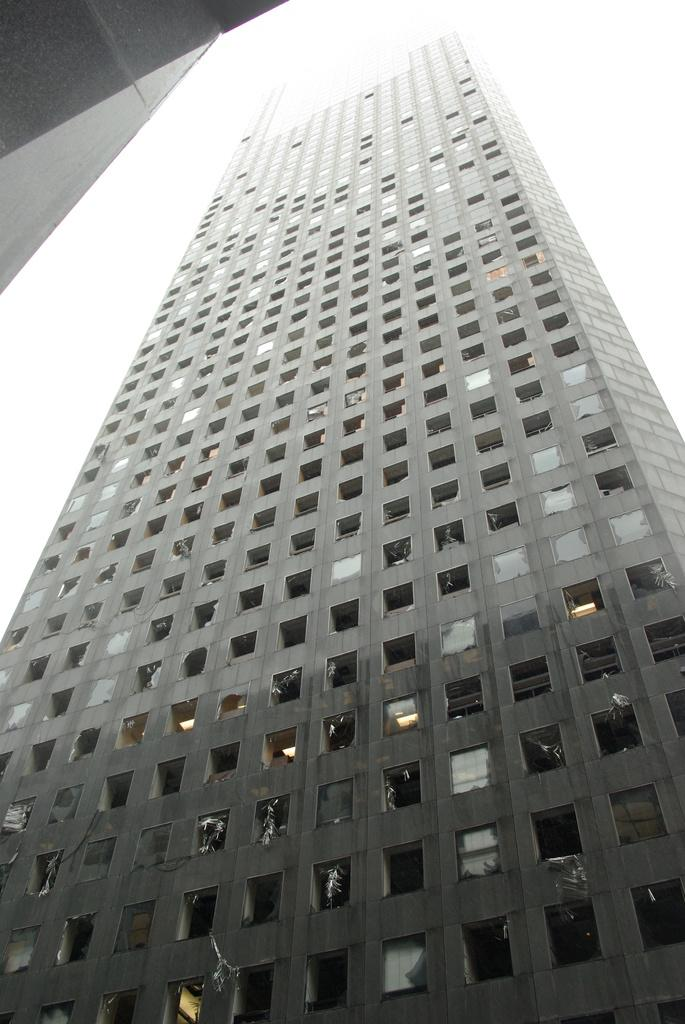What type of structure is the main subject of the image? There is a tall building in the image. Can you describe any other buildings visible in the image? There is another building visible in the image. What is the condition of the sky in the image? The sky is cloudy in the image. What type of jewel is being discussed in the meeting taking place in the image? There is no meeting or jewel present in the image; it features a tall building and another building with a cloudy sky. 